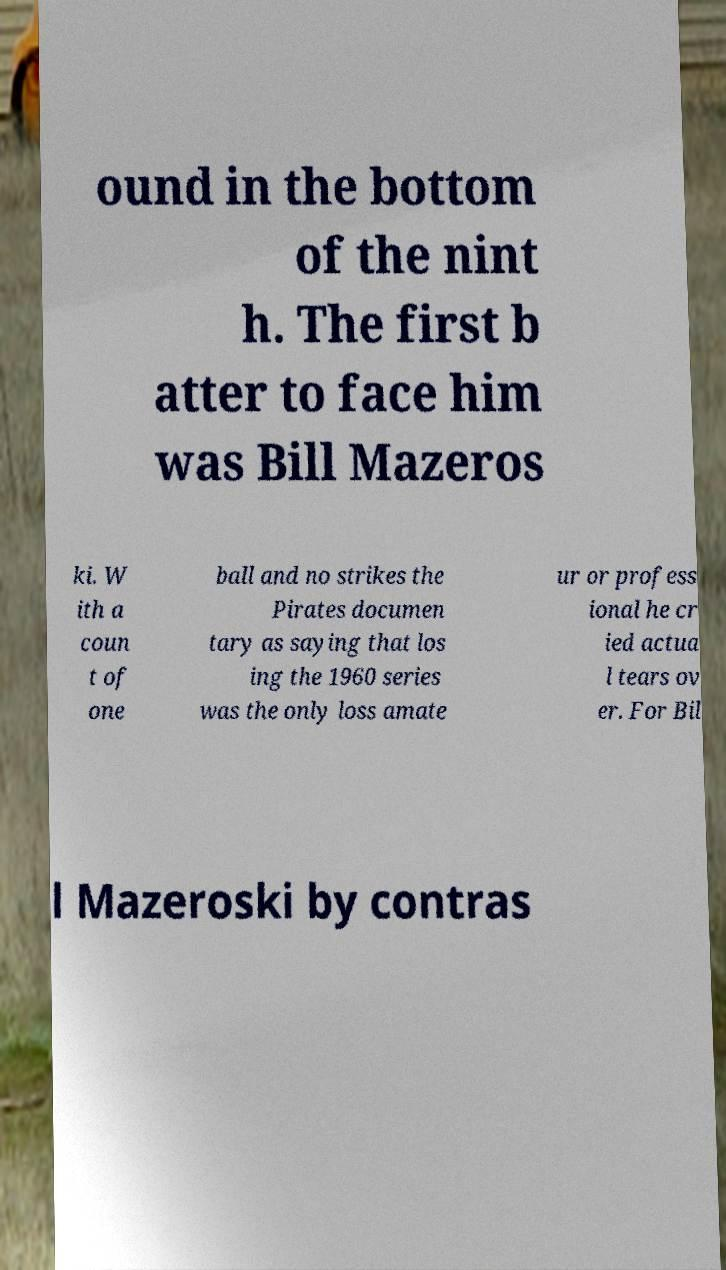Can you read and provide the text displayed in the image?This photo seems to have some interesting text. Can you extract and type it out for me? ound in the bottom of the nint h. The first b atter to face him was Bill Mazeros ki. W ith a coun t of one ball and no strikes the Pirates documen tary as saying that los ing the 1960 series was the only loss amate ur or profess ional he cr ied actua l tears ov er. For Bil l Mazeroski by contras 